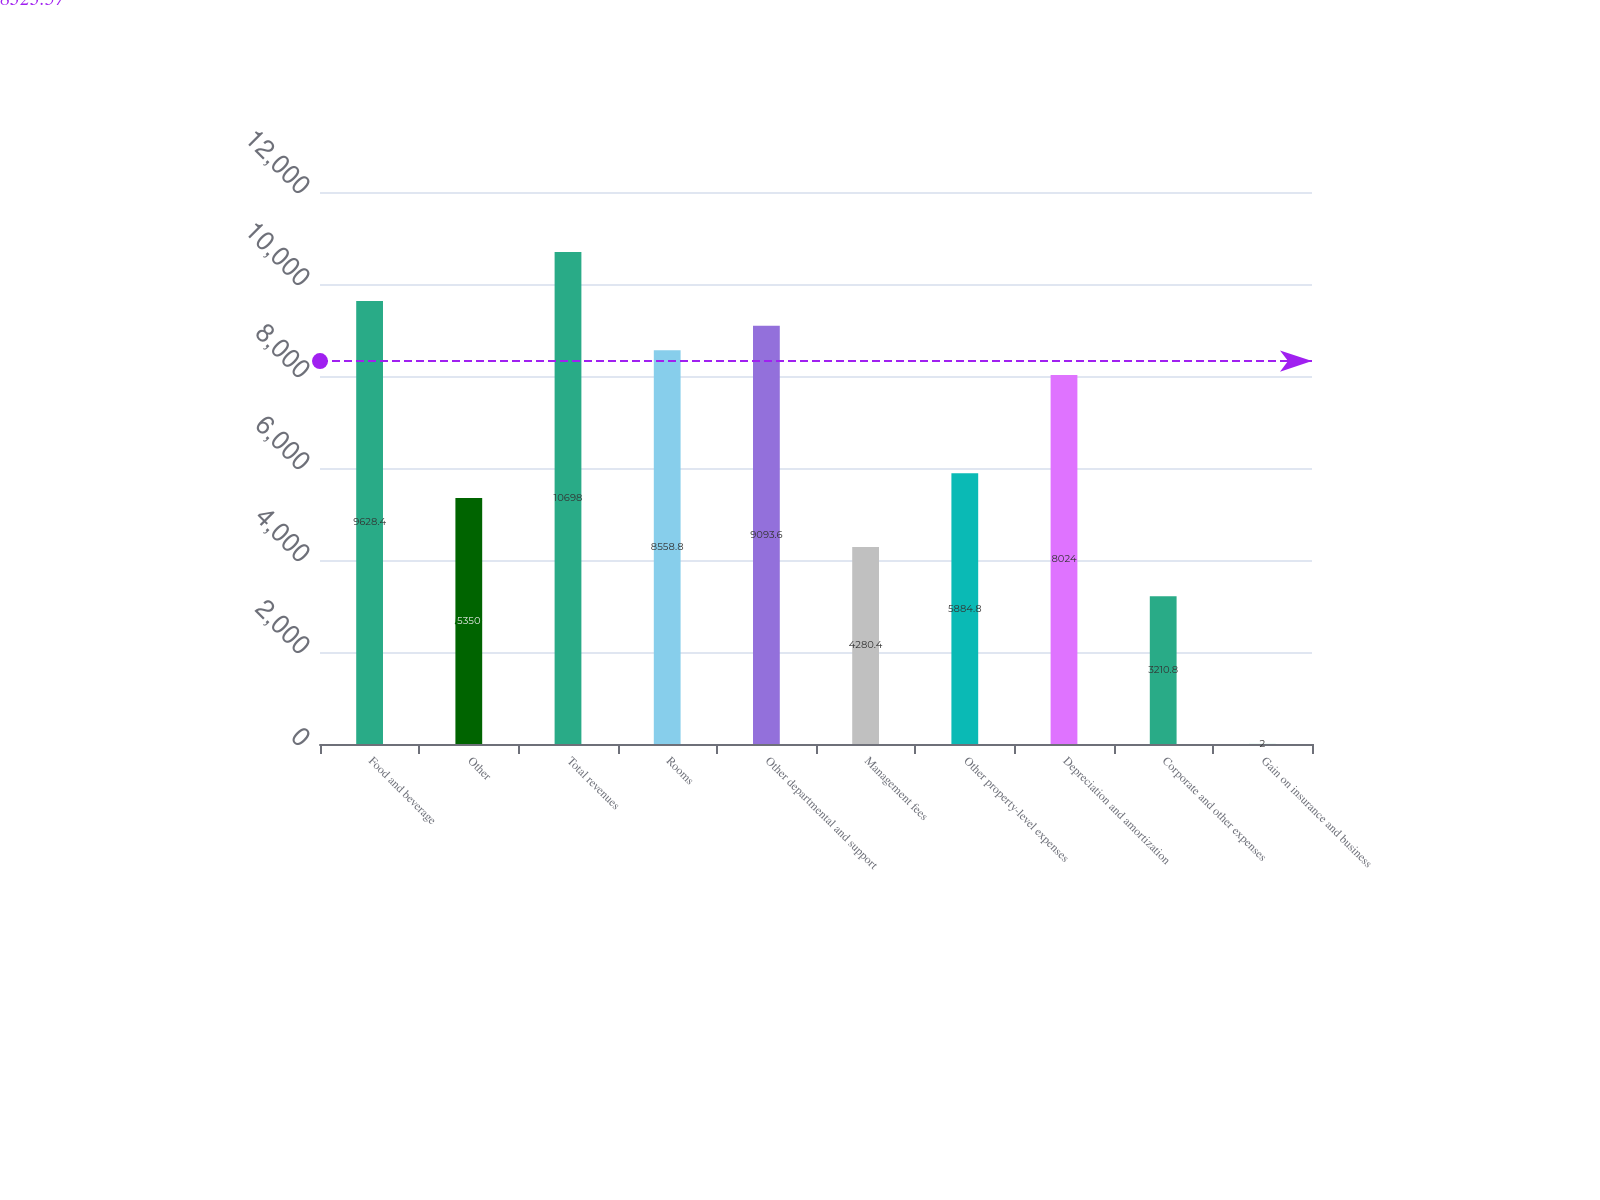<chart> <loc_0><loc_0><loc_500><loc_500><bar_chart><fcel>Food and beverage<fcel>Other<fcel>Total revenues<fcel>Rooms<fcel>Other departmental and support<fcel>Management fees<fcel>Other property-level expenses<fcel>Depreciation and amortization<fcel>Corporate and other expenses<fcel>Gain on insurance and business<nl><fcel>9628.4<fcel>5350<fcel>10698<fcel>8558.8<fcel>9093.6<fcel>4280.4<fcel>5884.8<fcel>8024<fcel>3210.8<fcel>2<nl></chart> 